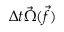<formula> <loc_0><loc_0><loc_500><loc_500>\Delta t \vec { \Omega } ( \ V e c { f } )</formula> 